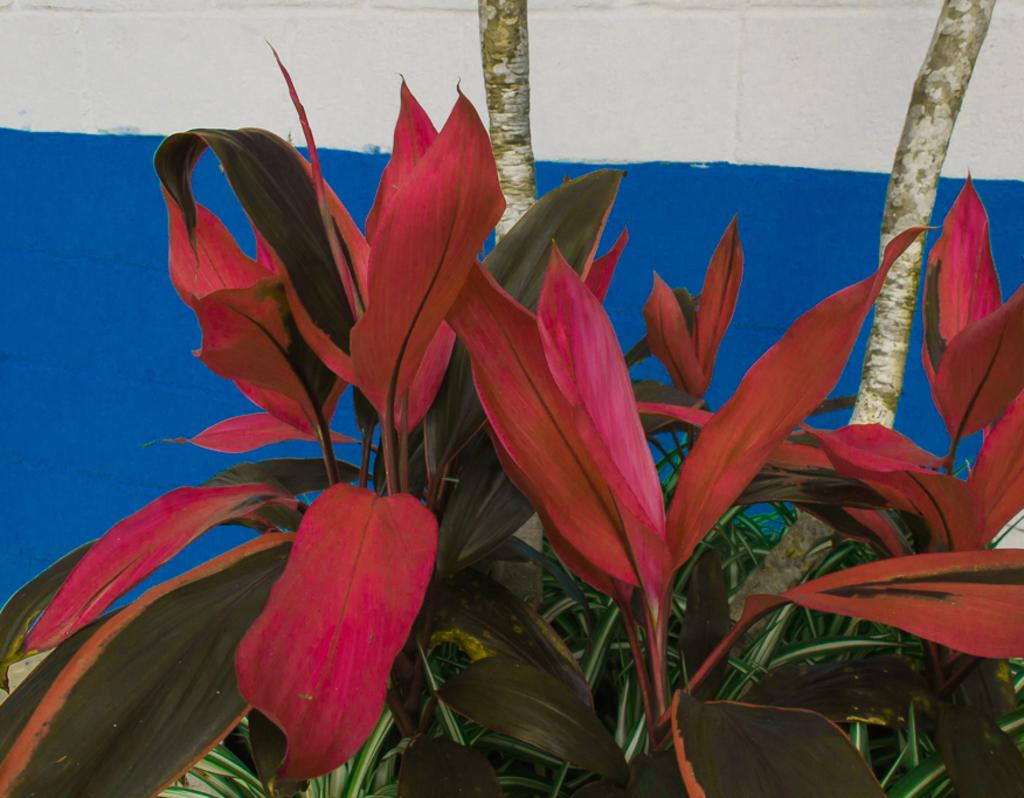What celestial bodies are depicted in the image? There are planets in the image. What type of natural feature can be seen in the image? There are branches in the image. What is visible in the background of the image? There is a wall in the background of the image. What type of skin condition can be seen on the planets in the image? There is no skin condition present in the image, as the planets are celestial bodies and not living organisms. 